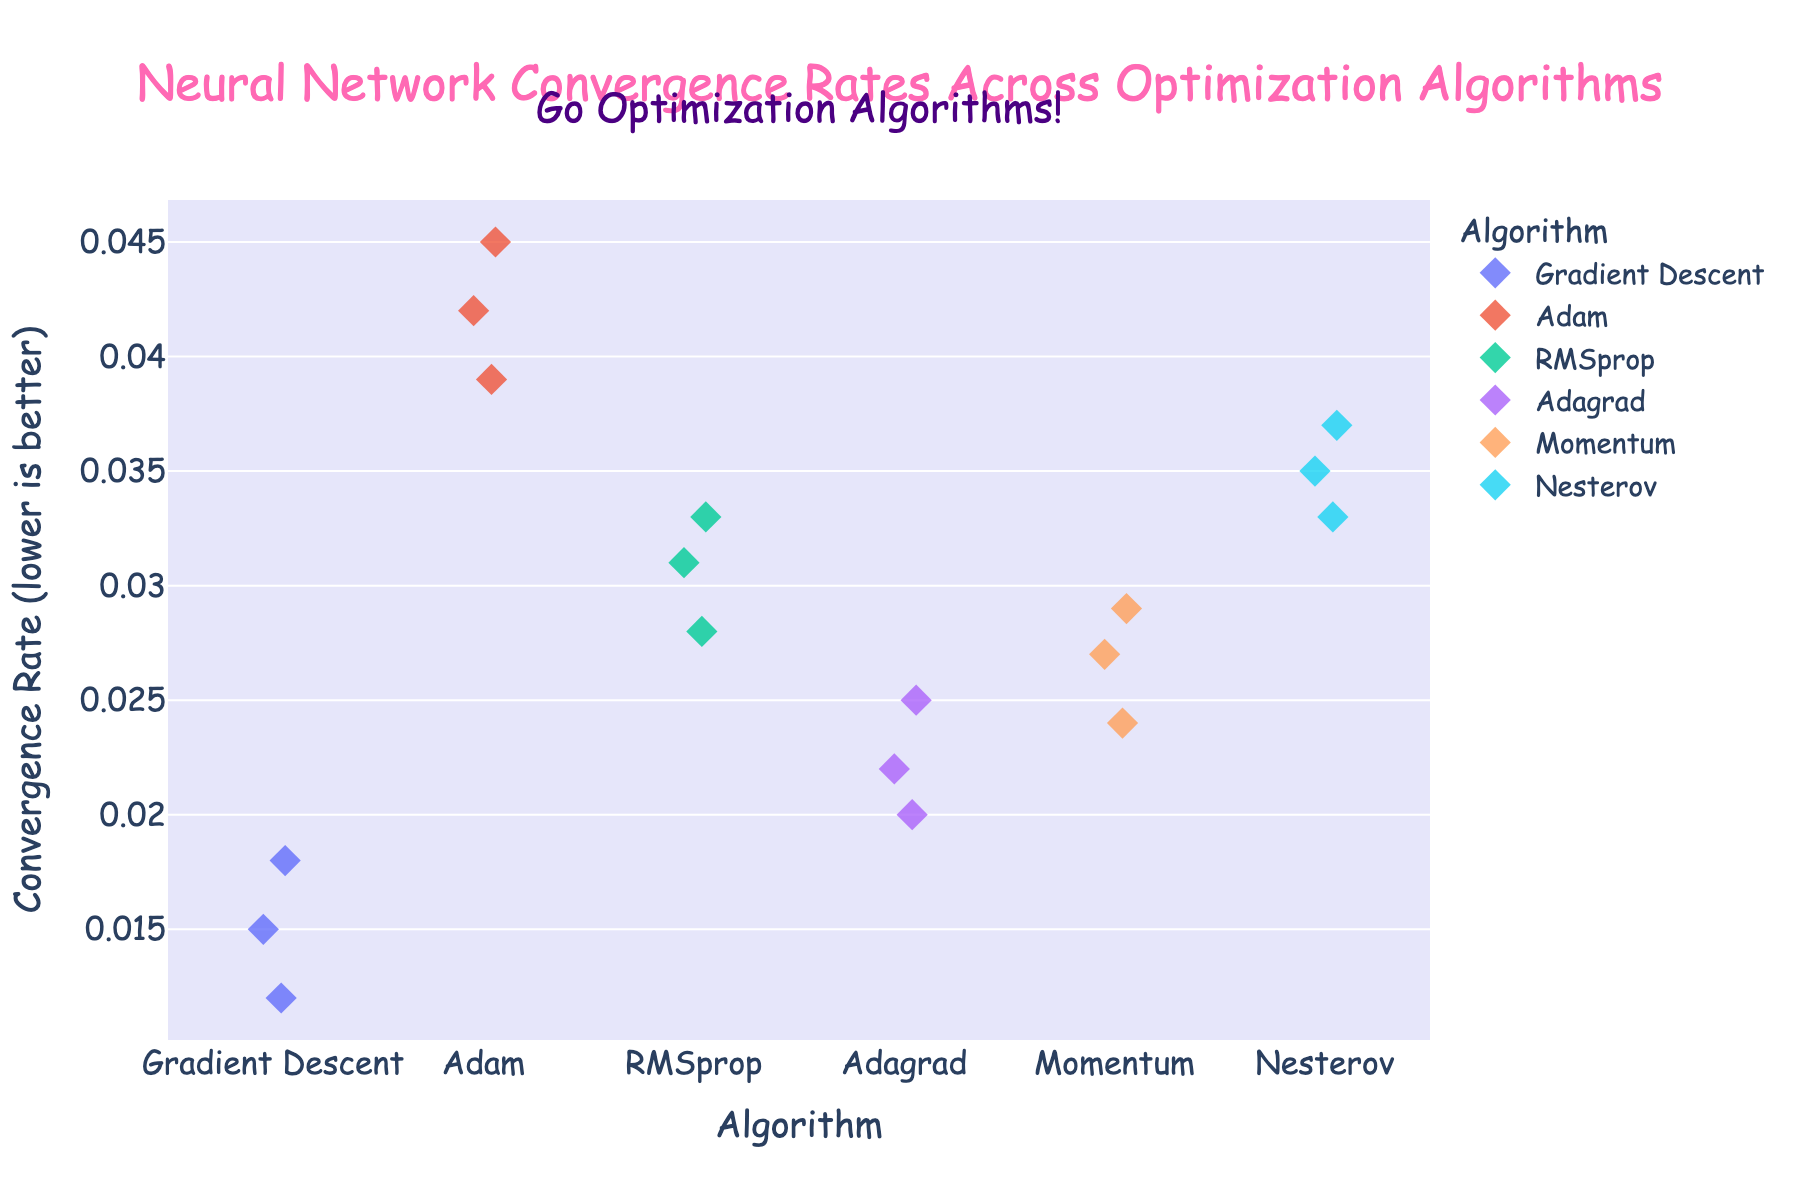What is the title of the figure? The title is usually displayed at the top of the figure, typically in a larger and bold font. In this figure, it is located there and reads "Neural Network Convergence Rates Across Optimization Algorithms".
Answer: Neural Network Convergence Rates Across Optimization Algorithms What color is used for the background of the plot? The background color of the plot is visually distinguishable and is a light shade, creating a pleasant contrast with the data points. It is light purple.
Answer: Light purple Which optimization algorithm has the highest recorded convergence rate? By looking at the strip plot, we can identify the convergence rates for each algorithm. The highest rate, indicated by the topmost data point, belongs to Adam with a rate of 0.045.
Answer: Adam How many data points are there for the Adagrad algorithm? Counting the visible markers (diamonds) associated with the Adagrad algorithm on the strip plot, we can see that there are three data points.
Answer: 3 Which algorithm has no outliers in the convergence rate values? An algorithm with no outliers will show all its data points clustering closely together. Examining the strip plot, Gradient Descent has its points more tightly grouped, suggesting no significant outliers compared to others.
Answer: Gradient Descent What is the range of convergence rates for the RMSprop algorithm? The range can be determined by subtracting the lowest convergence rate from the highest one for the RMSprop algorithm. The highest rate is 0.033, and the lowest is 0.028, giving us a range of 0.005.
Answer: 0.005 Which algorithm has the least variability in convergence rates? Observing the spread of the data points, the less dispersed they are, the lower the variability. Gradient Descent points are the closest to each other, indicating the least variability.
Answer: Gradient Descent How does the convergence rate of Adam compare to that of Adagrad? By examining the strip plots for Adam and Adagrad, we notice that Adam consistently has higher convergence rates compared to Adagrad's lower and more clustered rates. The highest convergence rates for Adam range around 0.045 while for Adagrad they hover around 0.025.
Answer: Higher What average convergence rate can be observed for the Nesterov algorithm? To find the average, first sum all the convergence rates for the Nesterov algorithm: 0.035 + 0.037 + 0.033 = 0.105. There are three data points, so the average is 0.105 / 3 = 0.035.
Answer: 0.035 